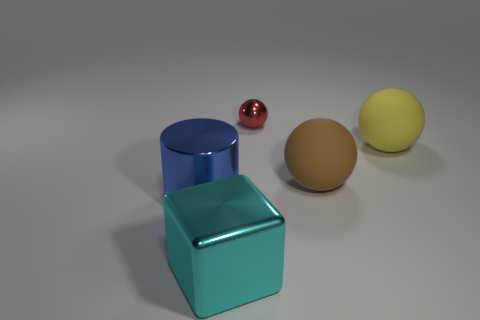Are there an equal number of big cyan things in front of the cyan metal cube and cyan shiny objects?
Give a very brief answer. No. What number of objects are tiny red shiny spheres or objects that are behind the big cylinder?
Your response must be concise. 3. Are there any large purple objects that have the same material as the small thing?
Your answer should be compact. No. There is another big thing that is the same shape as the large yellow matte object; what color is it?
Make the answer very short. Brown. Are the cyan thing and the big thing left of the big cyan metal object made of the same material?
Make the answer very short. Yes. The metallic object behind the object that is to the left of the big cube is what shape?
Provide a succinct answer. Sphere. There is a object that is to the left of the cyan cube; is it the same size as the brown object?
Provide a short and direct response. Yes. How many other objects are the same shape as the small object?
Your response must be concise. 2. Is there a matte object that has the same color as the big metal cube?
Keep it short and to the point. No. What number of small red spheres are in front of the large brown sphere?
Your response must be concise. 0. 